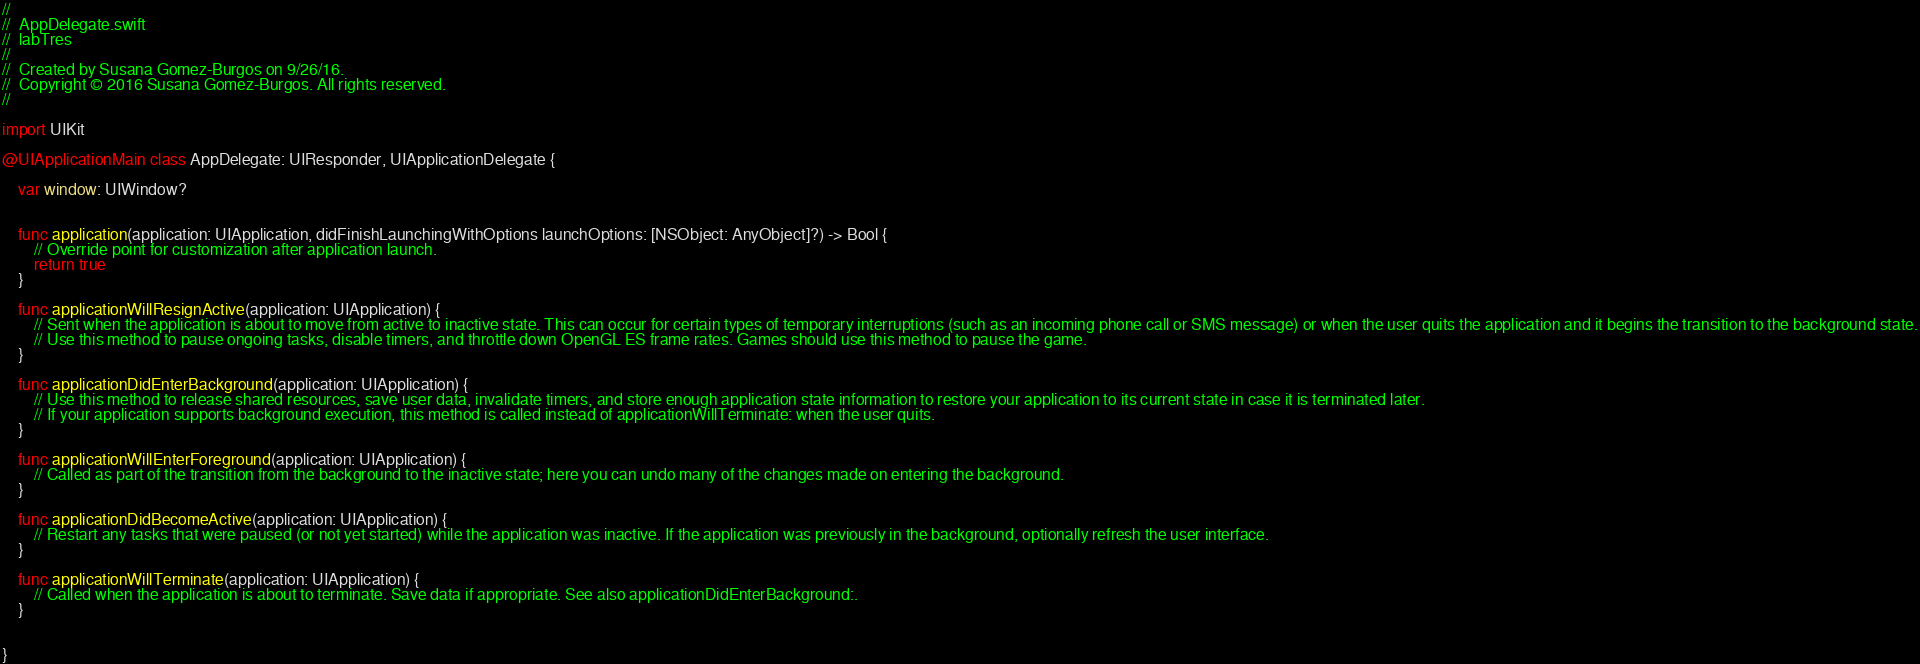Convert code to text. <code><loc_0><loc_0><loc_500><loc_500><_Swift_>//
//  AppDelegate.swift
//  labTres
//
//  Created by Susana Gomez-Burgos on 9/26/16.
//  Copyright © 2016 Susana Gomez-Burgos. All rights reserved.
//

import UIKit

@UIApplicationMain class AppDelegate: UIResponder, UIApplicationDelegate {

    var window: UIWindow?


    func application(application: UIApplication, didFinishLaunchingWithOptions launchOptions: [NSObject: AnyObject]?) -> Bool {
        // Override point for customization after application launch.
        return true
    }

    func applicationWillResignActive(application: UIApplication) {
        // Sent when the application is about to move from active to inactive state. This can occur for certain types of temporary interruptions (such as an incoming phone call or SMS message) or when the user quits the application and it begins the transition to the background state.
        // Use this method to pause ongoing tasks, disable timers, and throttle down OpenGL ES frame rates. Games should use this method to pause the game.
    }

    func applicationDidEnterBackground(application: UIApplication) {
        // Use this method to release shared resources, save user data, invalidate timers, and store enough application state information to restore your application to its current state in case it is terminated later.
        // If your application supports background execution, this method is called instead of applicationWillTerminate: when the user quits.
    }

    func applicationWillEnterForeground(application: UIApplication) {
        // Called as part of the transition from the background to the inactive state; here you can undo many of the changes made on entering the background.
    }

    func applicationDidBecomeActive(application: UIApplication) {
        // Restart any tasks that were paused (or not yet started) while the application was inactive. If the application was previously in the background, optionally refresh the user interface.
    }

    func applicationWillTerminate(application: UIApplication) {
        // Called when the application is about to terminate. Save data if appropriate. See also applicationDidEnterBackground:.
    }


}

</code> 